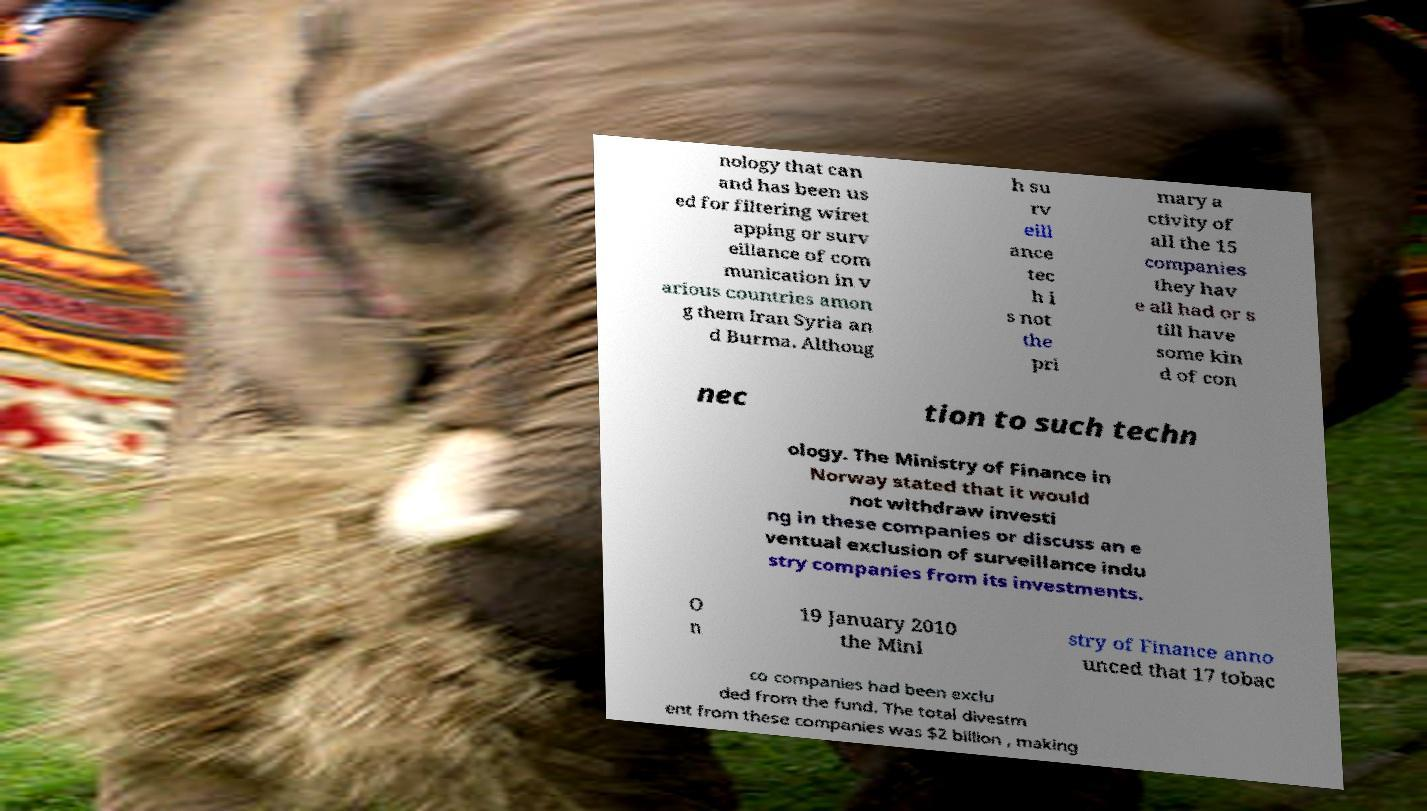Please read and relay the text visible in this image. What does it say? nology that can and has been us ed for filtering wiret apping or surv eillance of com munication in v arious countries amon g them Iran Syria an d Burma. Althoug h su rv eill ance tec h i s not the pri mary a ctivity of all the 15 companies they hav e all had or s till have some kin d of con nec tion to such techn ology. The Ministry of Finance in Norway stated that it would not withdraw investi ng in these companies or discuss an e ventual exclusion of surveillance indu stry companies from its investments. O n 19 January 2010 the Mini stry of Finance anno unced that 17 tobac co companies had been exclu ded from the fund. The total divestm ent from these companies was $2 billion , making 